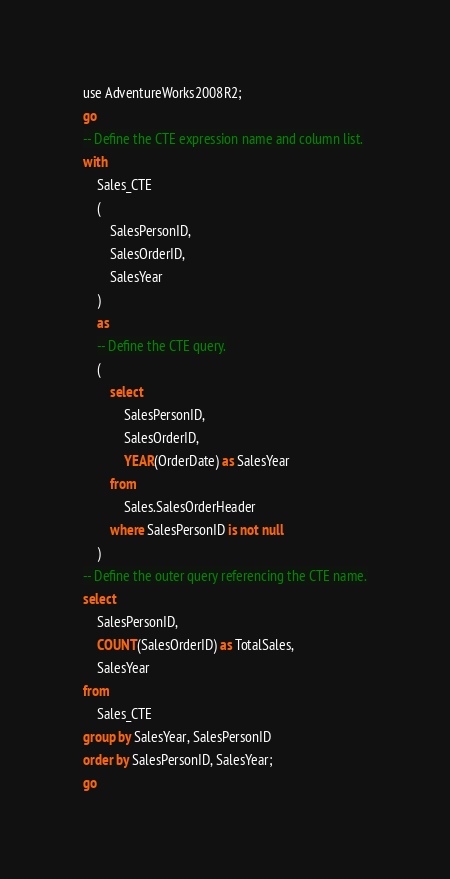Convert code to text. <code><loc_0><loc_0><loc_500><loc_500><_SQL_>use AdventureWorks2008R2;
go
-- Define the CTE expression name and column list.
with
    Sales_CTE
    (
        SalesPersonID,
        SalesOrderID,
        SalesYear
    )
    as
    -- Define the CTE query.
    (
        select
            SalesPersonID,
            SalesOrderID,
            YEAR(OrderDate) as SalesYear
        from
            Sales.SalesOrderHeader
        where SalesPersonID is not null
    )
-- Define the outer query referencing the CTE name.
select
    SalesPersonID,
    COUNT(SalesOrderID) as TotalSales,
    SalesYear
from
    Sales_CTE
group by SalesYear, SalesPersonID
order by SalesPersonID, SalesYear;
go

</code> 